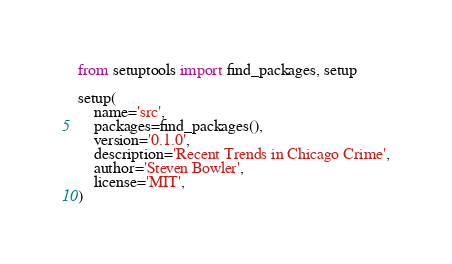<code> <loc_0><loc_0><loc_500><loc_500><_Python_>from setuptools import find_packages, setup

setup(
    name='src',
    packages=find_packages(),
    version='0.1.0',
    description='Recent Trends in Chicago Crime',
    author='Steven Bowler',
    license='MIT',
)
</code> 